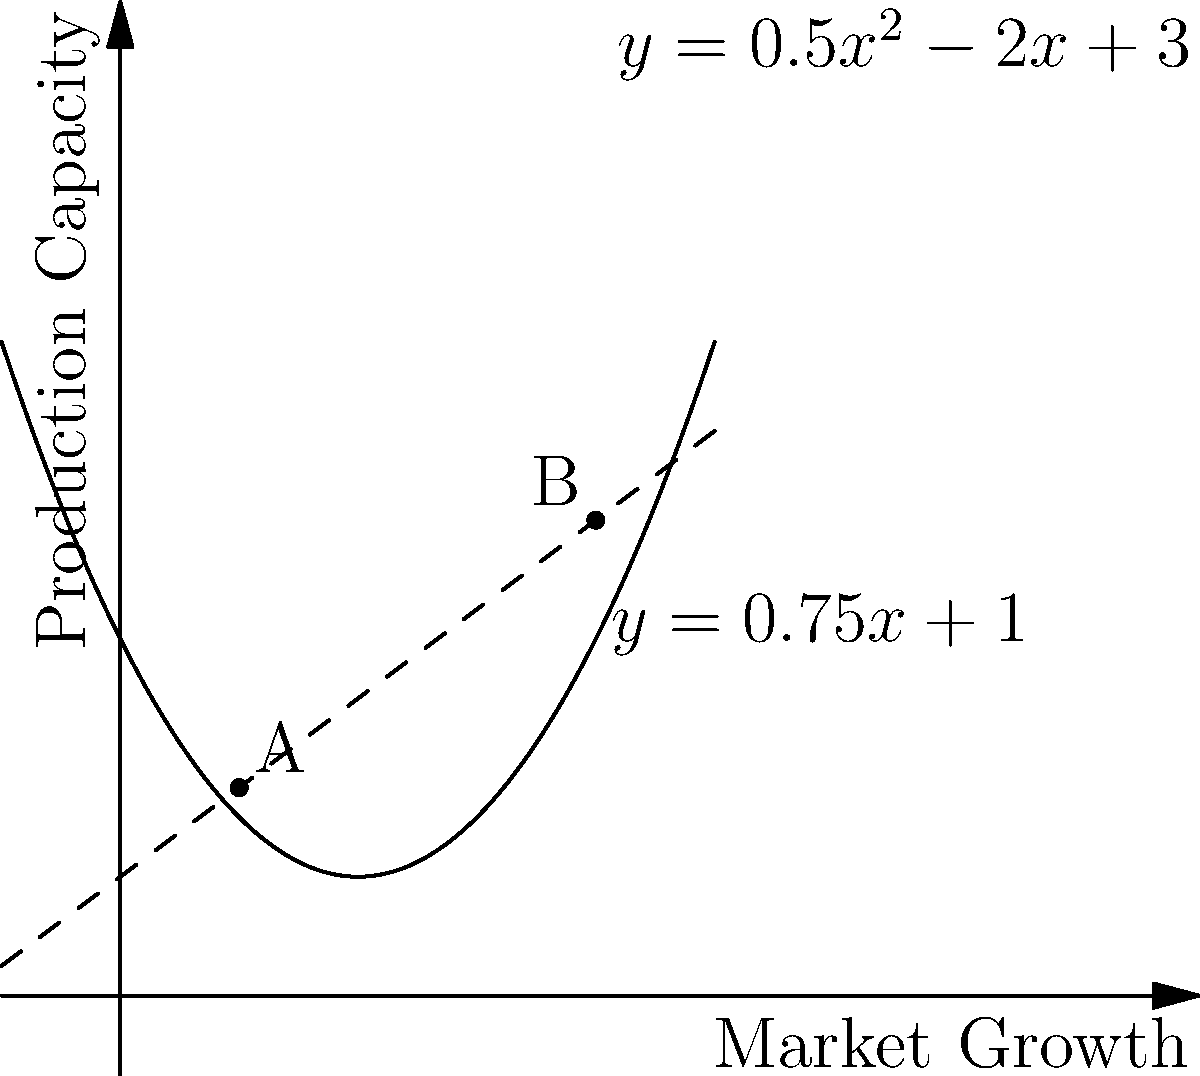As an entrepreneur, you're analyzing your company's market growth and production capacity. The parabola $y = 0.5x^2 - 2x + 3$ represents your market growth, while the line $y = 0.75x + 1$ represents your production capacity. At which point(s) does your production capacity meet market demand? Calculate the x-coordinate of the point where market growth is accelerating faster than production capacity can keep up. To solve this problem, we need to follow these steps:

1) Find the intersection points of the parabola and the line:
   $0.5x^2 - 2x + 3 = 0.75x + 1$
   $0.5x^2 - 2.75x + 2 = 0$

2) Solve this quadratic equation:
   $a = 0.5$, $b = -2.75$, $c = 2$
   Using the quadratic formula: $x = \frac{-b \pm \sqrt{b^2 - 4ac}}{2a}$
   $x = \frac{2.75 \pm \sqrt{7.5625 - 4}}{1} = \frac{2.75 \pm \sqrt{3.5625}}{1}$
   $x = \frac{2.75 \pm 1.8875}{1}$

3) This gives us two solutions:
   $x_1 = 1$ and $x_2 = 4$

4) These are the x-coordinates of points A and B in the graph.

5) To determine where market growth accelerates faster than production capacity, we need to find where the slope of the parabola exceeds the slope of the line.

6) The slope of the line is constant at 0.75.

7) The slope of the parabola is given by its derivative: $y' = x - 2$

8) Setting this equal to the line's slope:
   $x - 2 = 0.75$
   $x = 2.75$

9) This x-value (2.75) lies between the two intersection points (1 and 4).

Therefore, market growth accelerates faster than production capacity can keep up after $x = 2.75$, which corresponds to the x-coordinate of point B (4).
Answer: 4 